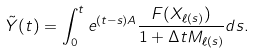<formula> <loc_0><loc_0><loc_500><loc_500>\tilde { Y } ( t ) = \int _ { 0 } ^ { t } e ^ { ( t - s ) A } \frac { F ( X _ { \ell ( s ) } ) } { 1 + \Delta t M _ { \ell ( s ) } } d s .</formula> 